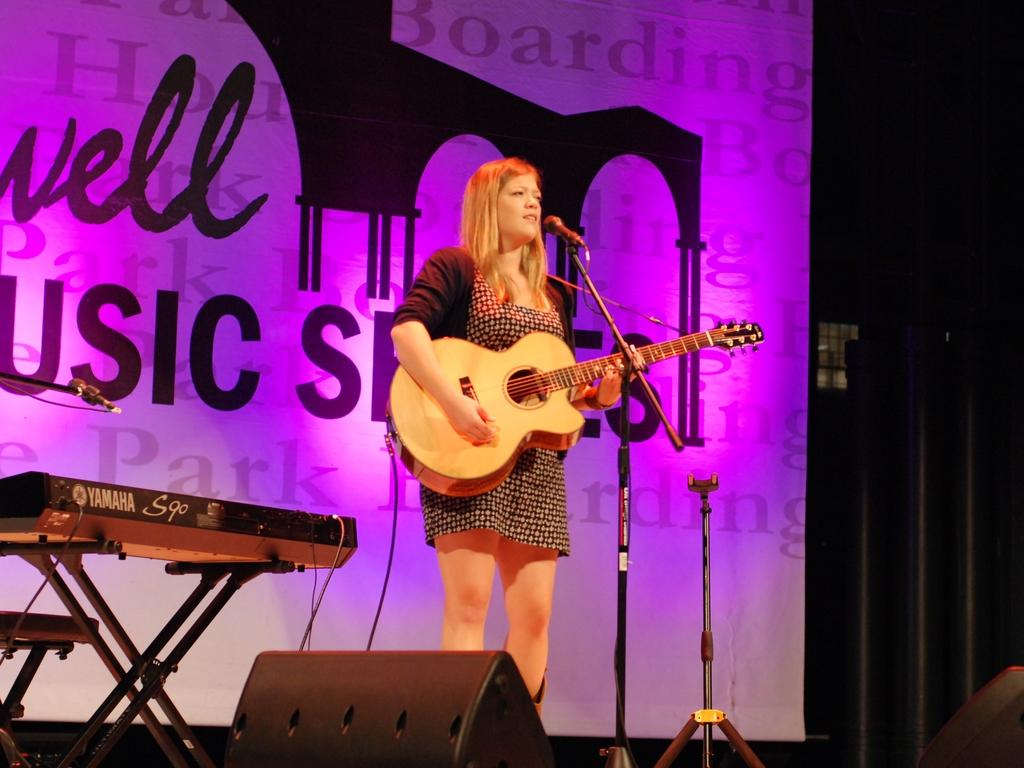Who is the main subject in the image? There is a woman in the image. What is the woman doing in the image? The woman is standing in the image. What object is the woman holding in her hand? The woman is holding a guitar in her hand. Can you see any harbors in the image? There is no harbor present in the image. Is the woman playing the guitar while running in the image? The woman is not running in the image; she is standing. Additionally, there is no indication of her playing the guitar in the image. 